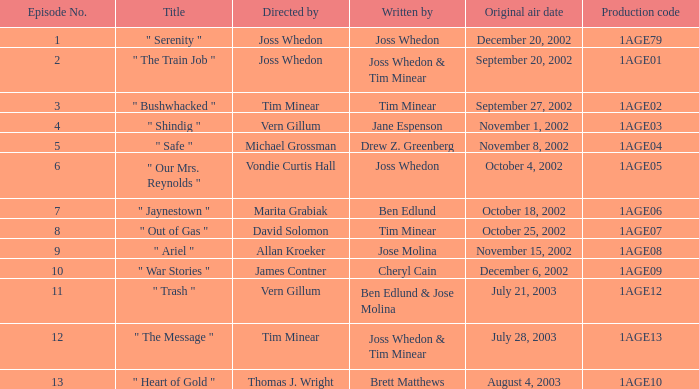What is the production code for the episode written by Drew Z. Greenberg? 1AGE04. 